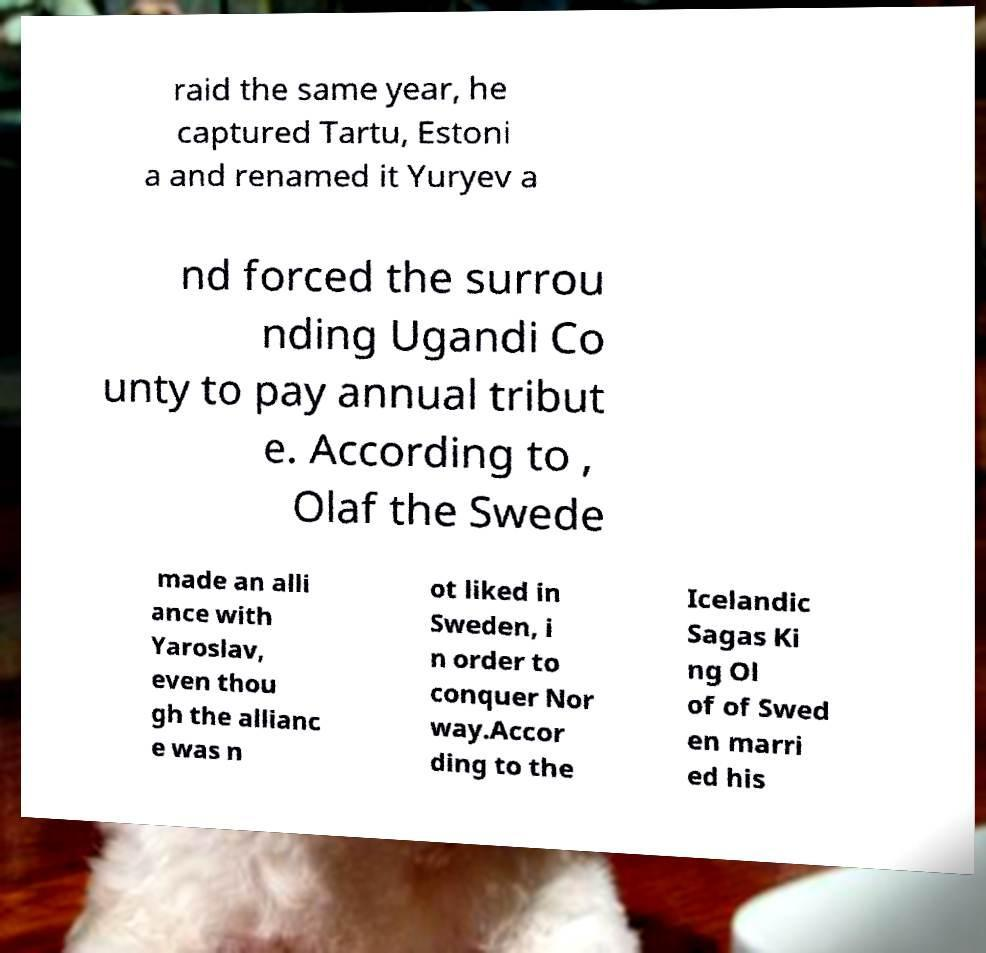Could you assist in decoding the text presented in this image and type it out clearly? raid the same year, he captured Tartu, Estoni a and renamed it Yuryev a nd forced the surrou nding Ugandi Co unty to pay annual tribut e. According to , Olaf the Swede made an alli ance with Yaroslav, even thou gh the allianc e was n ot liked in Sweden, i n order to conquer Nor way.Accor ding to the Icelandic Sagas Ki ng Ol of of Swed en marri ed his 